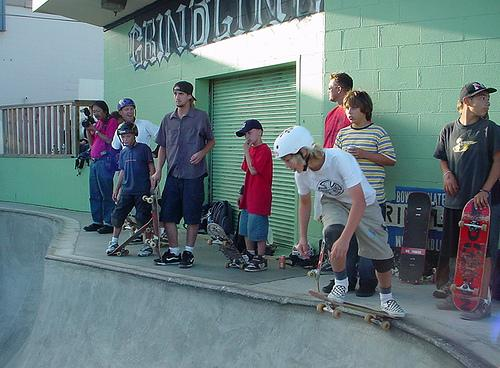What type of skate maneuver is the boy in white about to perform?

Choices:
A) drop in
B) wall ride
C) flip
D) manual drop in 